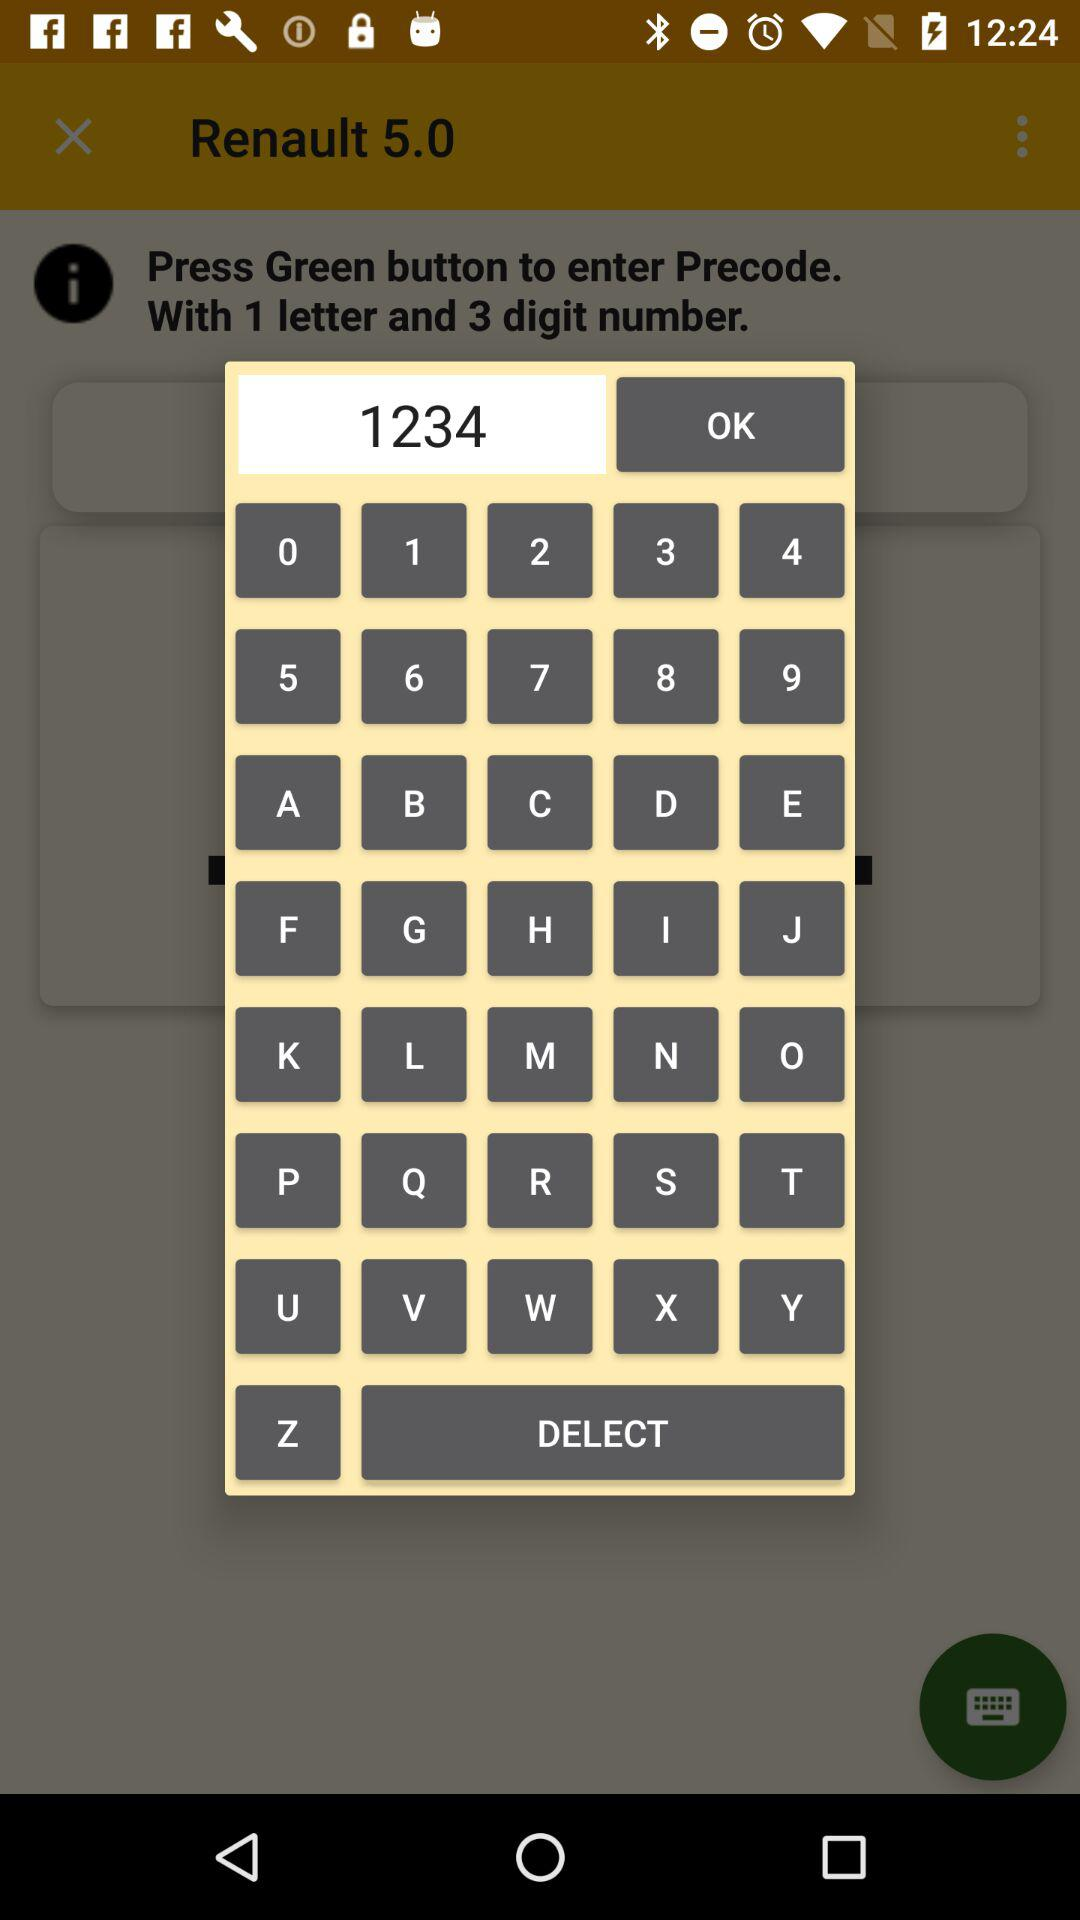How many numbers are in the text input field?
Answer the question using a single word or phrase. 4 